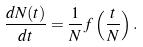<formula> <loc_0><loc_0><loc_500><loc_500>\frac { d N ( t ) } { d t } = \frac { 1 } { N } f \left ( \frac { t } { N } \right ) .</formula> 